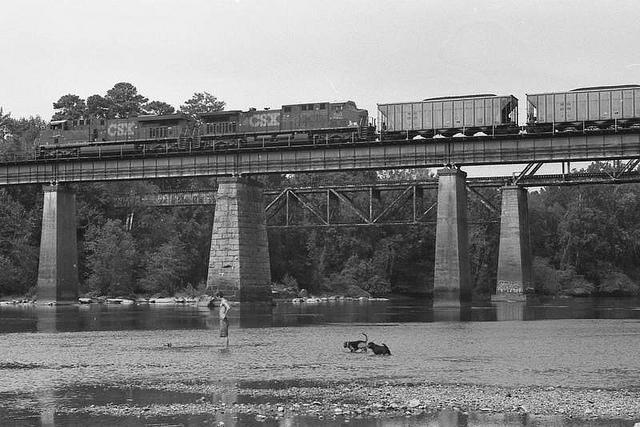Why is the train on a bridge?
Select the accurate answer and provide justification: `Answer: choice
Rationale: srationale.`
Options: Crossing river, stolen, is broken, lost. Answer: crossing river.
Rationale: To cross the river, the train must use the bridge. 